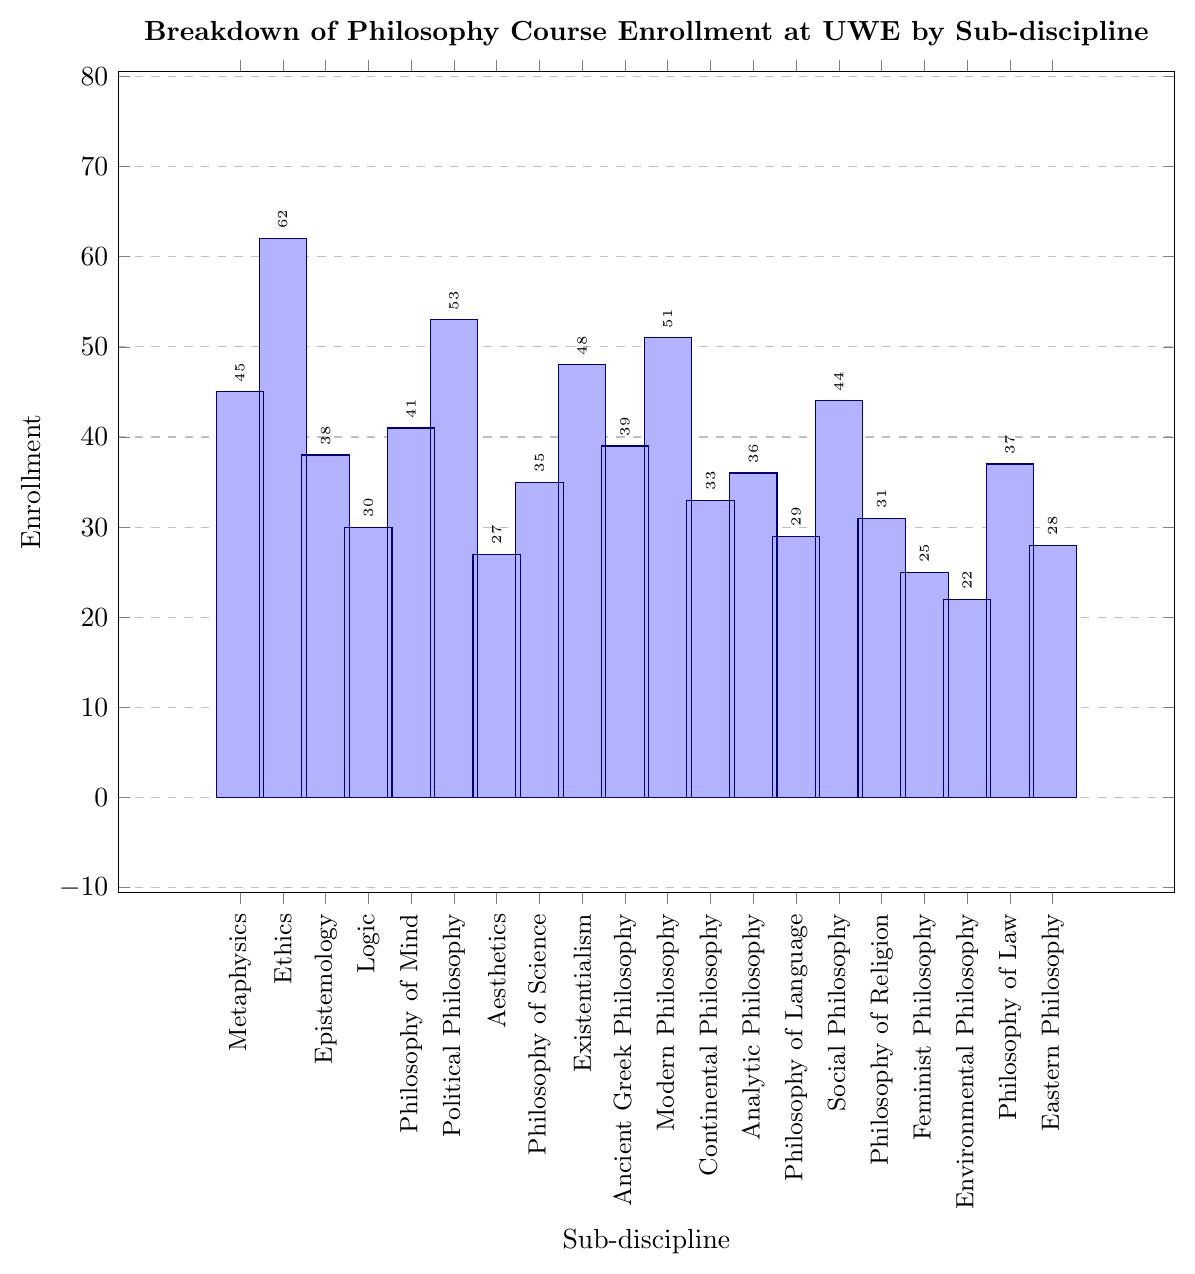what is the total enrollment in Ethics and Political Philosophy combined? To determine the total enrollment for Ethics and Political Philosophy, add the enrollments for both sub-disciplines. Ethics has an enrollment of 62, and Political Philosophy has 53. So, 62 + 53 = 115
Answer: 115 Which sub-discipline has the lowest enrollment? By observing the graph, the bar with the smallest height corresponds to Environmental Philosophy. Hence, Environmental Philosophy has the lowest enrollment.
Answer: Environmental Philosophy How much higher is the enrollment in Modern Philosophy compared to Ancient Greek Philosophy? According to the figure, Modern Philosophy has an enrollment of 51, while Ancient Greek Philosophy has 39. The difference is 51 - 39 = 12.
Answer: 12 What is the approximate median enrollment across all sub-disciplines? To find the median, first, list all enrollment values in ascending order: 22, 25, 27, 28, 29, 30, 31, 33, 35, 36, 37, 38, 39, 41, 44, 45, 48, 51, 53, 62. The median is the average of the 10th and 11th values. (36 + 37) / 2 = 36.5
Answer: 36.5 Which sub-discipline has a higher enrollment: Epistemology or Philosophy of Science? From the chart, Epistemology has an enrollment of 38, and Philosophy of Science has 35. Thus, Epistemology has a higher enrollment.
Answer: Epistemology How many sub-disciplines have an enrollment of 40 or higher? Count each sub-discipline whose bar extends to 40 or higher in the figure: Ethics (62), Political Philosophy (53), Modern Philosophy (51), Existentialism (48), Metaphysics (45), Social Philosophy (44), and Philosophy of Mind (41), which gives a total of 7.
Answer: 7 What's the ratio of students enrolled in Logic to those in Aesthetics? From the chart, Logic has an enrollment of 30, and Aesthetics has 27. The ratio is 30:27. Simplified, it is 10:9.
Answer: 10:9 